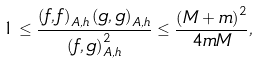<formula> <loc_0><loc_0><loc_500><loc_500>1 \leq \frac { \left ( f , f \right ) _ { A , h } \left ( g , g \right ) _ { A , h } } { \left ( f , g \right ) _ { A , h } ^ { 2 } } \leq \frac { \left ( M + m \right ) ^ { 2 } } { 4 m M } ,</formula> 